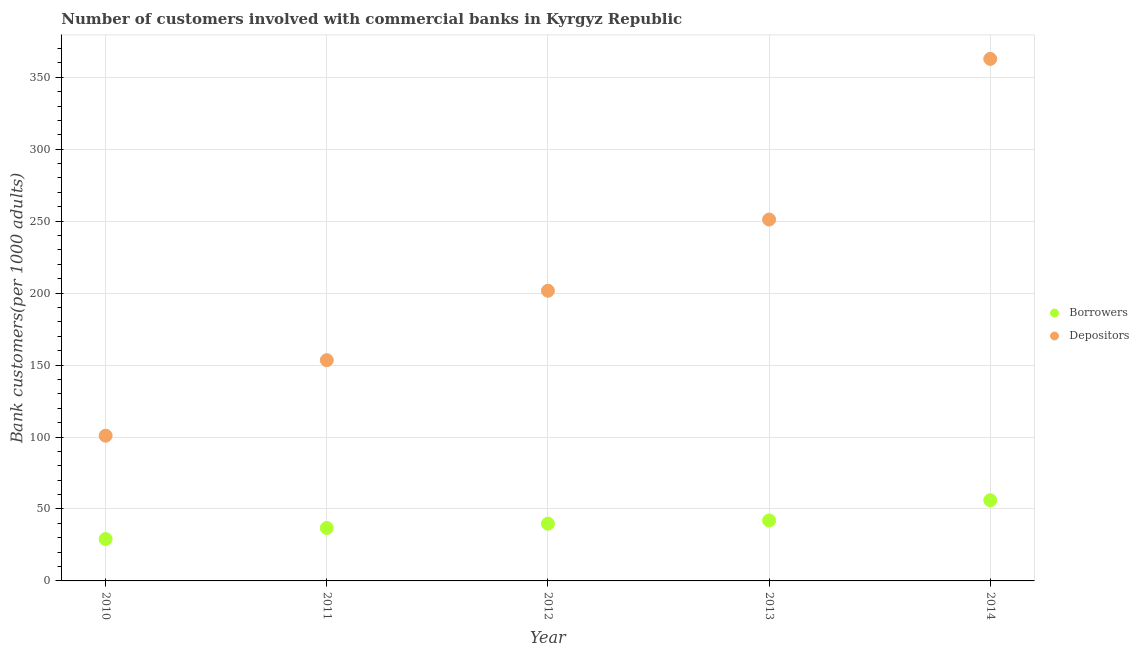Is the number of dotlines equal to the number of legend labels?
Your answer should be compact. Yes. What is the number of depositors in 2011?
Offer a terse response. 153.38. Across all years, what is the maximum number of borrowers?
Your answer should be very brief. 56.04. Across all years, what is the minimum number of borrowers?
Provide a succinct answer. 29.09. In which year was the number of borrowers maximum?
Offer a very short reply. 2014. What is the total number of depositors in the graph?
Keep it short and to the point. 1069.79. What is the difference between the number of depositors in 2010 and that in 2014?
Provide a short and direct response. -261.84. What is the difference between the number of depositors in 2014 and the number of borrowers in 2012?
Make the answer very short. 322.96. What is the average number of depositors per year?
Your answer should be very brief. 213.96. In the year 2010, what is the difference between the number of depositors and number of borrowers?
Ensure brevity in your answer.  71.81. What is the ratio of the number of depositors in 2011 to that in 2012?
Your answer should be compact. 0.76. Is the difference between the number of depositors in 2013 and 2014 greater than the difference between the number of borrowers in 2013 and 2014?
Give a very brief answer. No. What is the difference between the highest and the second highest number of borrowers?
Offer a terse response. 14.04. What is the difference between the highest and the lowest number of depositors?
Offer a terse response. 261.84. In how many years, is the number of depositors greater than the average number of depositors taken over all years?
Provide a short and direct response. 2. How many dotlines are there?
Give a very brief answer. 2. Are the values on the major ticks of Y-axis written in scientific E-notation?
Keep it short and to the point. No. Does the graph contain grids?
Your answer should be compact. Yes. Where does the legend appear in the graph?
Your answer should be very brief. Center right. What is the title of the graph?
Your answer should be compact. Number of customers involved with commercial banks in Kyrgyz Republic. What is the label or title of the X-axis?
Keep it short and to the point. Year. What is the label or title of the Y-axis?
Your response must be concise. Bank customers(per 1000 adults). What is the Bank customers(per 1000 adults) of Borrowers in 2010?
Keep it short and to the point. 29.09. What is the Bank customers(per 1000 adults) in Depositors in 2010?
Your answer should be compact. 100.91. What is the Bank customers(per 1000 adults) of Borrowers in 2011?
Provide a short and direct response. 36.78. What is the Bank customers(per 1000 adults) in Depositors in 2011?
Keep it short and to the point. 153.38. What is the Bank customers(per 1000 adults) in Borrowers in 2012?
Ensure brevity in your answer.  39.78. What is the Bank customers(per 1000 adults) of Depositors in 2012?
Provide a succinct answer. 201.64. What is the Bank customers(per 1000 adults) of Borrowers in 2013?
Your answer should be compact. 42. What is the Bank customers(per 1000 adults) of Depositors in 2013?
Your response must be concise. 251.12. What is the Bank customers(per 1000 adults) in Borrowers in 2014?
Provide a short and direct response. 56.04. What is the Bank customers(per 1000 adults) of Depositors in 2014?
Give a very brief answer. 362.74. Across all years, what is the maximum Bank customers(per 1000 adults) in Borrowers?
Keep it short and to the point. 56.04. Across all years, what is the maximum Bank customers(per 1000 adults) in Depositors?
Offer a very short reply. 362.74. Across all years, what is the minimum Bank customers(per 1000 adults) of Borrowers?
Offer a very short reply. 29.09. Across all years, what is the minimum Bank customers(per 1000 adults) in Depositors?
Give a very brief answer. 100.91. What is the total Bank customers(per 1000 adults) in Borrowers in the graph?
Your answer should be very brief. 203.69. What is the total Bank customers(per 1000 adults) in Depositors in the graph?
Provide a succinct answer. 1069.79. What is the difference between the Bank customers(per 1000 adults) in Borrowers in 2010 and that in 2011?
Your answer should be compact. -7.68. What is the difference between the Bank customers(per 1000 adults) in Depositors in 2010 and that in 2011?
Give a very brief answer. -52.48. What is the difference between the Bank customers(per 1000 adults) in Borrowers in 2010 and that in 2012?
Ensure brevity in your answer.  -10.69. What is the difference between the Bank customers(per 1000 adults) of Depositors in 2010 and that in 2012?
Offer a terse response. -100.73. What is the difference between the Bank customers(per 1000 adults) in Borrowers in 2010 and that in 2013?
Provide a short and direct response. -12.9. What is the difference between the Bank customers(per 1000 adults) of Depositors in 2010 and that in 2013?
Make the answer very short. -150.21. What is the difference between the Bank customers(per 1000 adults) of Borrowers in 2010 and that in 2014?
Ensure brevity in your answer.  -26.95. What is the difference between the Bank customers(per 1000 adults) of Depositors in 2010 and that in 2014?
Your answer should be very brief. -261.84. What is the difference between the Bank customers(per 1000 adults) in Borrowers in 2011 and that in 2012?
Your answer should be compact. -3. What is the difference between the Bank customers(per 1000 adults) in Depositors in 2011 and that in 2012?
Make the answer very short. -48.25. What is the difference between the Bank customers(per 1000 adults) of Borrowers in 2011 and that in 2013?
Ensure brevity in your answer.  -5.22. What is the difference between the Bank customers(per 1000 adults) in Depositors in 2011 and that in 2013?
Your answer should be very brief. -97.73. What is the difference between the Bank customers(per 1000 adults) of Borrowers in 2011 and that in 2014?
Keep it short and to the point. -19.26. What is the difference between the Bank customers(per 1000 adults) of Depositors in 2011 and that in 2014?
Give a very brief answer. -209.36. What is the difference between the Bank customers(per 1000 adults) in Borrowers in 2012 and that in 2013?
Give a very brief answer. -2.22. What is the difference between the Bank customers(per 1000 adults) of Depositors in 2012 and that in 2013?
Offer a very short reply. -49.48. What is the difference between the Bank customers(per 1000 adults) in Borrowers in 2012 and that in 2014?
Your answer should be very brief. -16.26. What is the difference between the Bank customers(per 1000 adults) of Depositors in 2012 and that in 2014?
Your response must be concise. -161.11. What is the difference between the Bank customers(per 1000 adults) of Borrowers in 2013 and that in 2014?
Your answer should be very brief. -14.04. What is the difference between the Bank customers(per 1000 adults) of Depositors in 2013 and that in 2014?
Offer a very short reply. -111.63. What is the difference between the Bank customers(per 1000 adults) of Borrowers in 2010 and the Bank customers(per 1000 adults) of Depositors in 2011?
Keep it short and to the point. -124.29. What is the difference between the Bank customers(per 1000 adults) in Borrowers in 2010 and the Bank customers(per 1000 adults) in Depositors in 2012?
Ensure brevity in your answer.  -172.54. What is the difference between the Bank customers(per 1000 adults) in Borrowers in 2010 and the Bank customers(per 1000 adults) in Depositors in 2013?
Keep it short and to the point. -222.02. What is the difference between the Bank customers(per 1000 adults) in Borrowers in 2010 and the Bank customers(per 1000 adults) in Depositors in 2014?
Give a very brief answer. -333.65. What is the difference between the Bank customers(per 1000 adults) of Borrowers in 2011 and the Bank customers(per 1000 adults) of Depositors in 2012?
Make the answer very short. -164.86. What is the difference between the Bank customers(per 1000 adults) of Borrowers in 2011 and the Bank customers(per 1000 adults) of Depositors in 2013?
Provide a succinct answer. -214.34. What is the difference between the Bank customers(per 1000 adults) of Borrowers in 2011 and the Bank customers(per 1000 adults) of Depositors in 2014?
Make the answer very short. -325.97. What is the difference between the Bank customers(per 1000 adults) in Borrowers in 2012 and the Bank customers(per 1000 adults) in Depositors in 2013?
Your response must be concise. -211.34. What is the difference between the Bank customers(per 1000 adults) of Borrowers in 2012 and the Bank customers(per 1000 adults) of Depositors in 2014?
Make the answer very short. -322.96. What is the difference between the Bank customers(per 1000 adults) in Borrowers in 2013 and the Bank customers(per 1000 adults) in Depositors in 2014?
Give a very brief answer. -320.75. What is the average Bank customers(per 1000 adults) in Borrowers per year?
Provide a succinct answer. 40.74. What is the average Bank customers(per 1000 adults) in Depositors per year?
Your response must be concise. 213.96. In the year 2010, what is the difference between the Bank customers(per 1000 adults) in Borrowers and Bank customers(per 1000 adults) in Depositors?
Keep it short and to the point. -71.81. In the year 2011, what is the difference between the Bank customers(per 1000 adults) of Borrowers and Bank customers(per 1000 adults) of Depositors?
Ensure brevity in your answer.  -116.61. In the year 2012, what is the difference between the Bank customers(per 1000 adults) of Borrowers and Bank customers(per 1000 adults) of Depositors?
Provide a short and direct response. -161.86. In the year 2013, what is the difference between the Bank customers(per 1000 adults) of Borrowers and Bank customers(per 1000 adults) of Depositors?
Keep it short and to the point. -209.12. In the year 2014, what is the difference between the Bank customers(per 1000 adults) of Borrowers and Bank customers(per 1000 adults) of Depositors?
Give a very brief answer. -306.7. What is the ratio of the Bank customers(per 1000 adults) in Borrowers in 2010 to that in 2011?
Your answer should be compact. 0.79. What is the ratio of the Bank customers(per 1000 adults) in Depositors in 2010 to that in 2011?
Your answer should be compact. 0.66. What is the ratio of the Bank customers(per 1000 adults) of Borrowers in 2010 to that in 2012?
Provide a succinct answer. 0.73. What is the ratio of the Bank customers(per 1000 adults) in Depositors in 2010 to that in 2012?
Your response must be concise. 0.5. What is the ratio of the Bank customers(per 1000 adults) in Borrowers in 2010 to that in 2013?
Provide a succinct answer. 0.69. What is the ratio of the Bank customers(per 1000 adults) in Depositors in 2010 to that in 2013?
Provide a succinct answer. 0.4. What is the ratio of the Bank customers(per 1000 adults) in Borrowers in 2010 to that in 2014?
Give a very brief answer. 0.52. What is the ratio of the Bank customers(per 1000 adults) of Depositors in 2010 to that in 2014?
Ensure brevity in your answer.  0.28. What is the ratio of the Bank customers(per 1000 adults) in Borrowers in 2011 to that in 2012?
Your response must be concise. 0.92. What is the ratio of the Bank customers(per 1000 adults) of Depositors in 2011 to that in 2012?
Make the answer very short. 0.76. What is the ratio of the Bank customers(per 1000 adults) in Borrowers in 2011 to that in 2013?
Keep it short and to the point. 0.88. What is the ratio of the Bank customers(per 1000 adults) of Depositors in 2011 to that in 2013?
Make the answer very short. 0.61. What is the ratio of the Bank customers(per 1000 adults) in Borrowers in 2011 to that in 2014?
Provide a short and direct response. 0.66. What is the ratio of the Bank customers(per 1000 adults) in Depositors in 2011 to that in 2014?
Ensure brevity in your answer.  0.42. What is the ratio of the Bank customers(per 1000 adults) of Borrowers in 2012 to that in 2013?
Your answer should be compact. 0.95. What is the ratio of the Bank customers(per 1000 adults) in Depositors in 2012 to that in 2013?
Your answer should be very brief. 0.8. What is the ratio of the Bank customers(per 1000 adults) of Borrowers in 2012 to that in 2014?
Keep it short and to the point. 0.71. What is the ratio of the Bank customers(per 1000 adults) of Depositors in 2012 to that in 2014?
Your answer should be very brief. 0.56. What is the ratio of the Bank customers(per 1000 adults) in Borrowers in 2013 to that in 2014?
Your answer should be compact. 0.75. What is the ratio of the Bank customers(per 1000 adults) in Depositors in 2013 to that in 2014?
Offer a terse response. 0.69. What is the difference between the highest and the second highest Bank customers(per 1000 adults) of Borrowers?
Your response must be concise. 14.04. What is the difference between the highest and the second highest Bank customers(per 1000 adults) of Depositors?
Keep it short and to the point. 111.63. What is the difference between the highest and the lowest Bank customers(per 1000 adults) of Borrowers?
Make the answer very short. 26.95. What is the difference between the highest and the lowest Bank customers(per 1000 adults) in Depositors?
Offer a terse response. 261.84. 